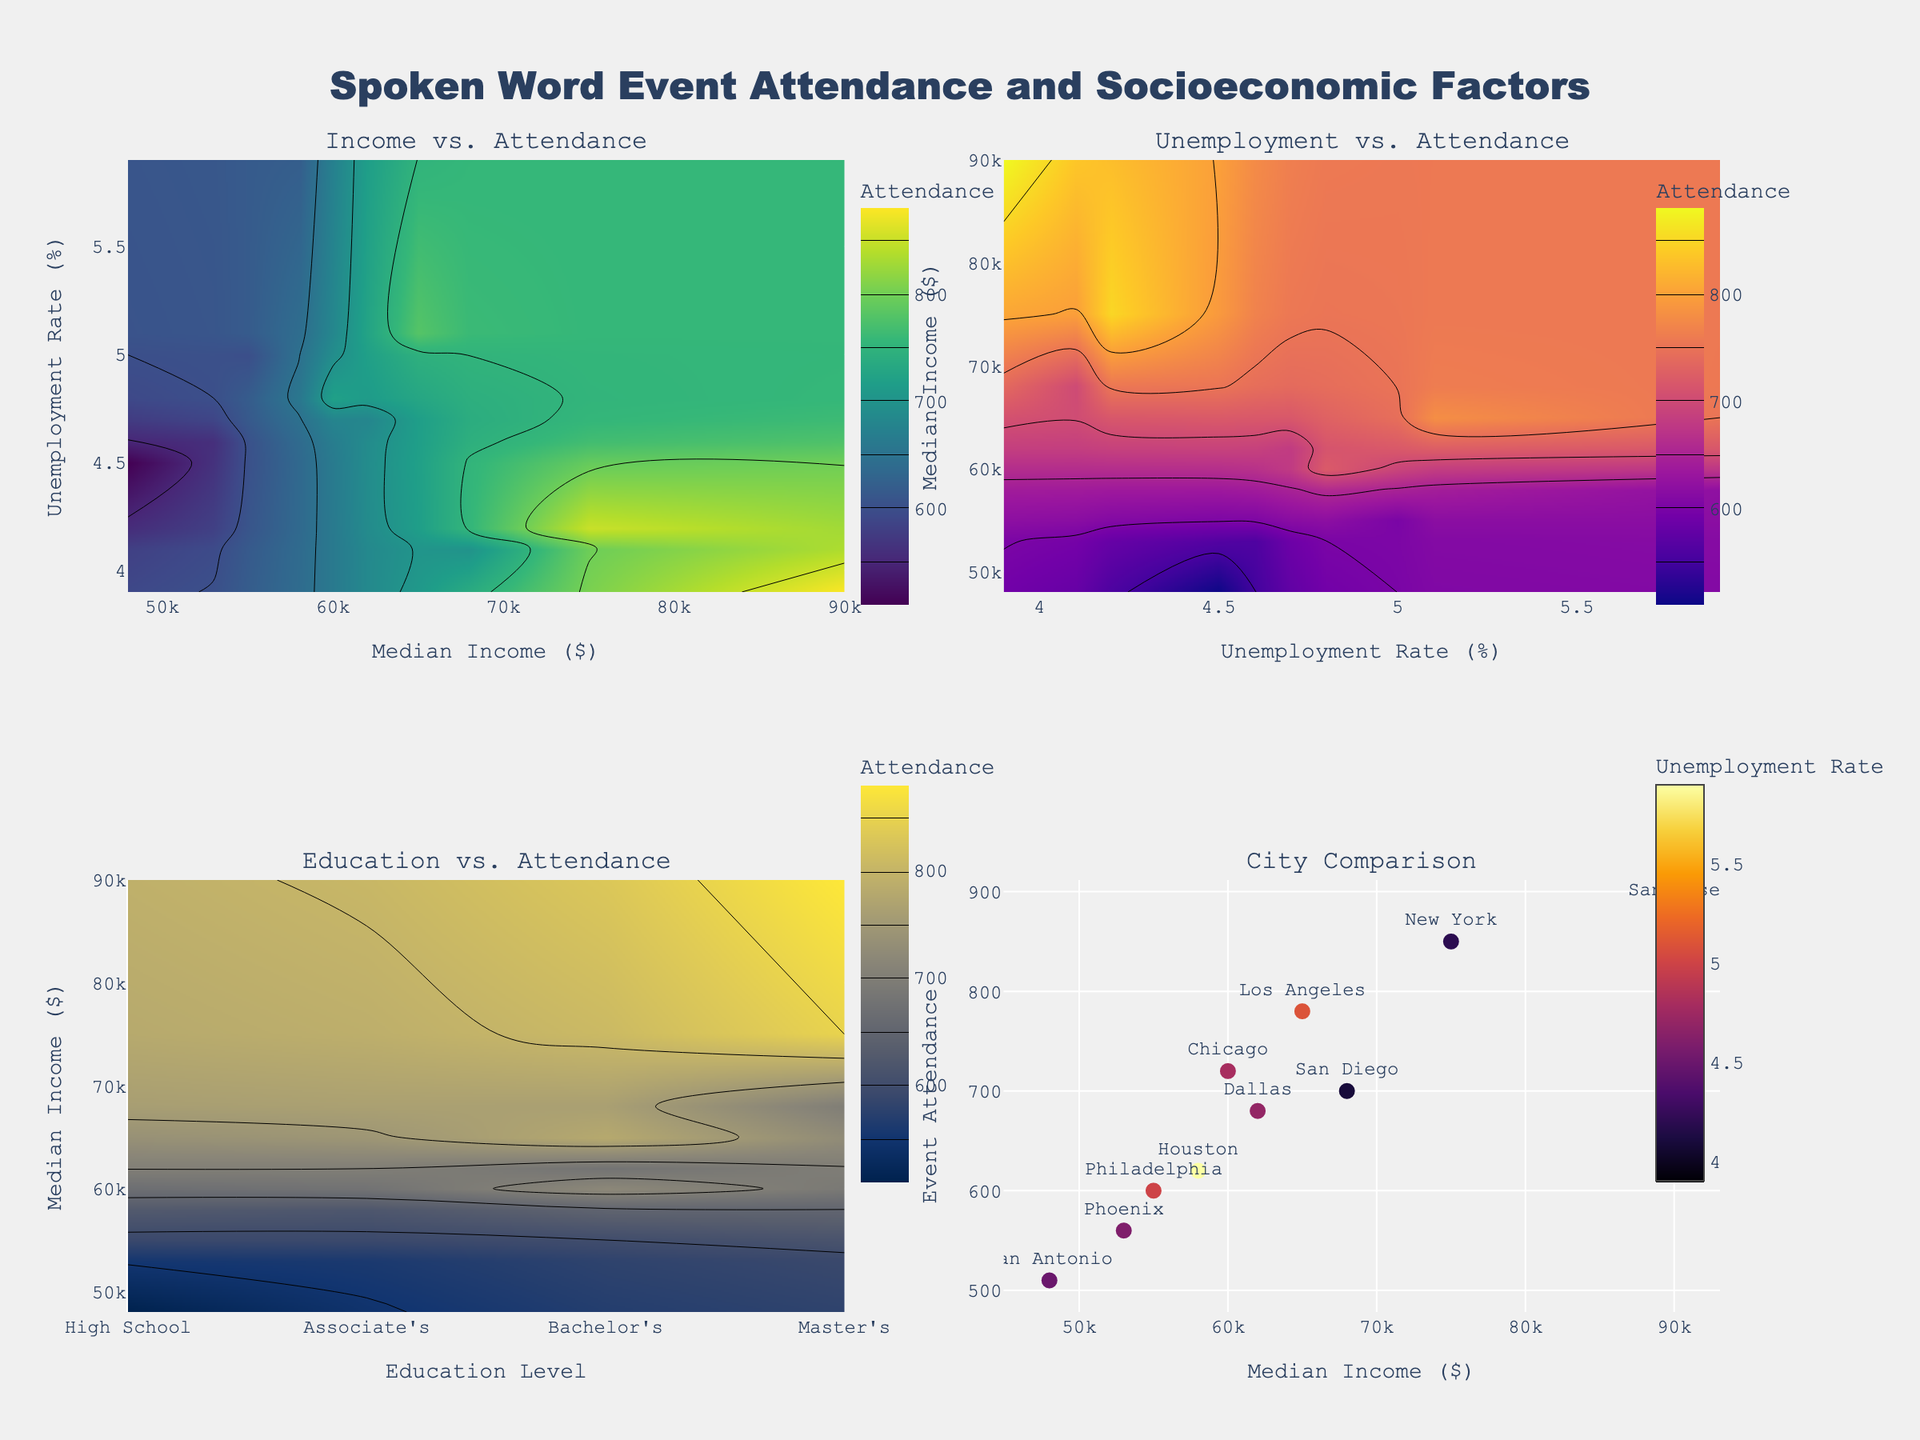What is the title of the figure? The title of the figure is prominently displayed above all the subplots. It reads "Spoken Word Event Attendance and Socioeconomic Factors".
Answer: Spoken Word Event Attendance and Socioeconomic Factors What are the x and y axes in the "Income vs. Attendance" subplot? In the "Income vs. Attendance" subplot, the x-axis represents Median Income in dollars, and the y-axis represents Unemployment Rate in percentage.
Answer: Median Income in dollars, Unemployment Rate in percentage What is the color scale used in the "Unemployment vs. Attendance" subplot? The color scale used in the "Unemployment vs. Attendance" subplot is Plasma, which progresses from darker to lighter shades to represent varying levels of attendance.
Answer: Plasma Which city has the highest event attendance, and what is its median income? By locating the city names in the "City Comparison" subplot, San Jose has the highest event attendance. The text indicates it has a median income of $90,000.
Answer: San Jose, $90,000 Which subplot uses a scatter plot instead of a contour plot? The "City Comparison" subplot uses a scatter plot, whereas the other three subplots use contour plots.
Answer: City Comparison How is education level represented in the "Education vs. Attendance" subplot? In the "Education vs. Attendance" subplot, education level is represented by codes on the x-axis ranging from 0 to 3, where 0 is High School, 1 is Associate's, 2 is Bachelor's, and 3 is Master's.
Answer: 0: High School, 1: Associate's, 2: Bachelor's, 3: Master's Which city has the lowest median income and what is its event attendance? Looking at the "City Comparison" subplot, San Antonio has the lowest median income of $48,000, and its event attendance is 510.
Answer: San Antonio, 510 Between San Diego and Dallas, which city has a higher event attendance, and what are their median incomes? From the "City Comparison" subplot, San Diego has an attendance of 700 and a median income of $68,000, while Dallas has an attendance of 680 and a median income of $62,000. San Diego has a higher attendance.
Answer: San Diego, $68,000; Dallas, $62,000 What is the unemployment rate of New York, and how does it compare to Los Angeles? Referring to the city names in the plots, New York's unemployment rate is 4.2%, while Los Angeles's is 5.1%. New York has a lower unemployment rate.
Answer: New York: 4.2%, Los Angeles: 5.1% Is there a visible relationship between higher education levels and event attendance in the "Education vs. Attendance" subplot? By examining the gradient of the contour plot in the "Education vs. Attendance" subplot, there seems to be a trend where higher education levels are associated with higher event attendance, as indicated by the axis and color gradients.
Answer: Higher education levels are associated with higher attendance 